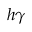Convert formula to latex. <formula><loc_0><loc_0><loc_500><loc_500>h \gamma</formula> 